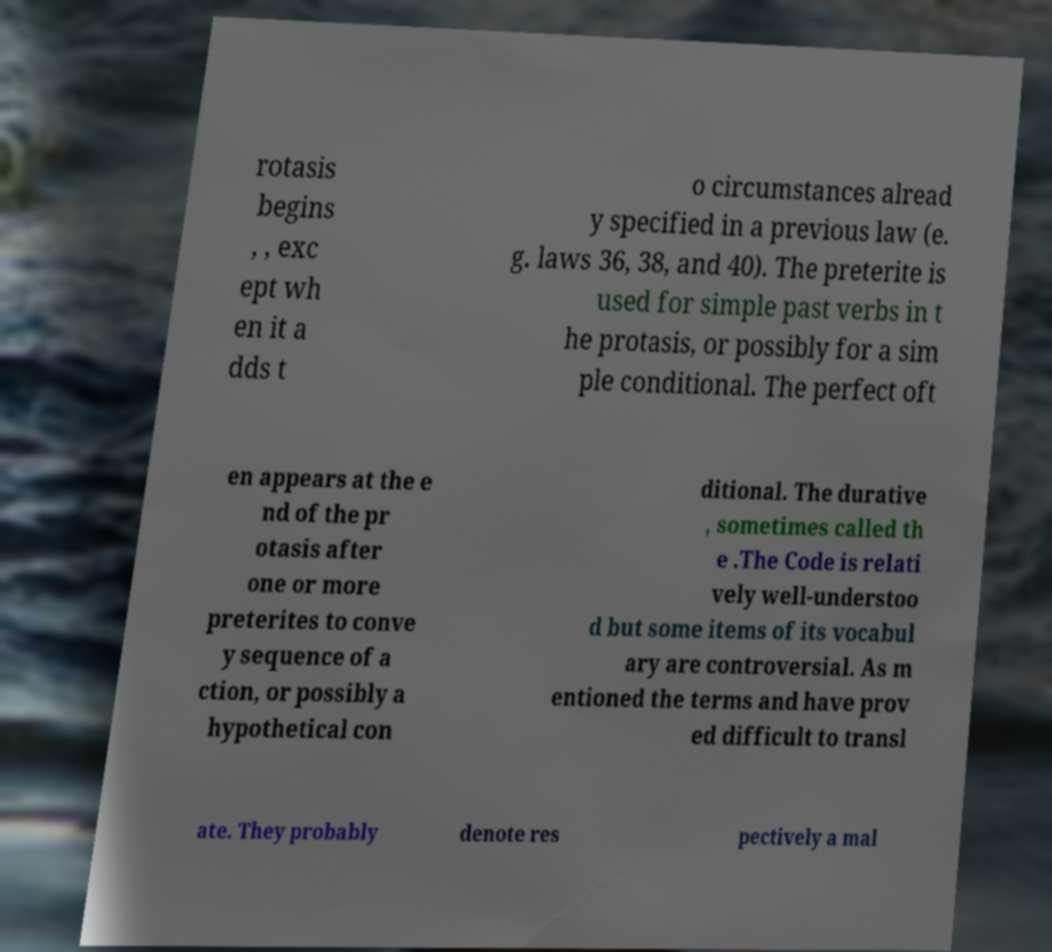Can you accurately transcribe the text from the provided image for me? rotasis begins , , exc ept wh en it a dds t o circumstances alread y specified in a previous law (e. g. laws 36, 38, and 40). The preterite is used for simple past verbs in t he protasis, or possibly for a sim ple conditional. The perfect oft en appears at the e nd of the pr otasis after one or more preterites to conve y sequence of a ction, or possibly a hypothetical con ditional. The durative , sometimes called th e .The Code is relati vely well-understoo d but some items of its vocabul ary are controversial. As m entioned the terms and have prov ed difficult to transl ate. They probably denote res pectively a mal 